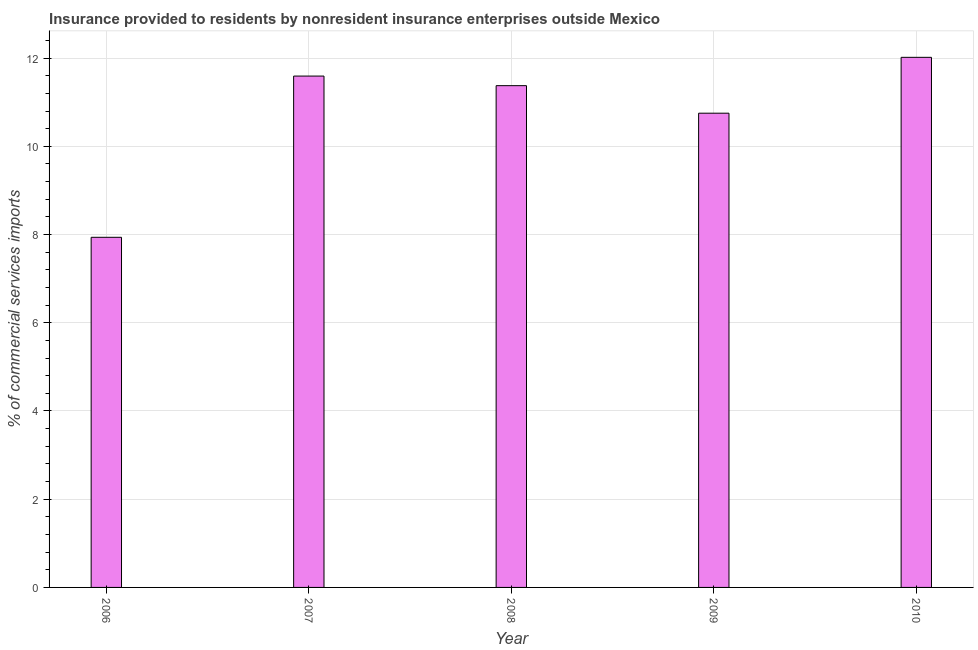Does the graph contain any zero values?
Provide a short and direct response. No. What is the title of the graph?
Provide a succinct answer. Insurance provided to residents by nonresident insurance enterprises outside Mexico. What is the label or title of the X-axis?
Offer a terse response. Year. What is the label or title of the Y-axis?
Keep it short and to the point. % of commercial services imports. What is the insurance provided by non-residents in 2007?
Your response must be concise. 11.59. Across all years, what is the maximum insurance provided by non-residents?
Your answer should be compact. 12.02. Across all years, what is the minimum insurance provided by non-residents?
Keep it short and to the point. 7.94. In which year was the insurance provided by non-residents maximum?
Give a very brief answer. 2010. What is the sum of the insurance provided by non-residents?
Your answer should be very brief. 53.68. What is the difference between the insurance provided by non-residents in 2006 and 2010?
Offer a very short reply. -4.08. What is the average insurance provided by non-residents per year?
Offer a terse response. 10.73. What is the median insurance provided by non-residents?
Offer a terse response. 11.38. What is the ratio of the insurance provided by non-residents in 2009 to that in 2010?
Provide a succinct answer. 0.9. What is the difference between the highest and the second highest insurance provided by non-residents?
Your response must be concise. 0.42. What is the difference between the highest and the lowest insurance provided by non-residents?
Ensure brevity in your answer.  4.08. In how many years, is the insurance provided by non-residents greater than the average insurance provided by non-residents taken over all years?
Your answer should be very brief. 4. How many bars are there?
Ensure brevity in your answer.  5. How many years are there in the graph?
Make the answer very short. 5. What is the difference between two consecutive major ticks on the Y-axis?
Provide a short and direct response. 2. Are the values on the major ticks of Y-axis written in scientific E-notation?
Your answer should be very brief. No. What is the % of commercial services imports in 2006?
Provide a succinct answer. 7.94. What is the % of commercial services imports of 2007?
Offer a terse response. 11.59. What is the % of commercial services imports in 2008?
Your answer should be compact. 11.38. What is the % of commercial services imports of 2009?
Ensure brevity in your answer.  10.75. What is the % of commercial services imports in 2010?
Provide a succinct answer. 12.02. What is the difference between the % of commercial services imports in 2006 and 2007?
Your response must be concise. -3.66. What is the difference between the % of commercial services imports in 2006 and 2008?
Your answer should be very brief. -3.44. What is the difference between the % of commercial services imports in 2006 and 2009?
Keep it short and to the point. -2.81. What is the difference between the % of commercial services imports in 2006 and 2010?
Your answer should be compact. -4.08. What is the difference between the % of commercial services imports in 2007 and 2008?
Make the answer very short. 0.22. What is the difference between the % of commercial services imports in 2007 and 2009?
Your answer should be compact. 0.84. What is the difference between the % of commercial services imports in 2007 and 2010?
Offer a very short reply. -0.42. What is the difference between the % of commercial services imports in 2008 and 2009?
Provide a short and direct response. 0.62. What is the difference between the % of commercial services imports in 2008 and 2010?
Your answer should be compact. -0.64. What is the difference between the % of commercial services imports in 2009 and 2010?
Offer a very short reply. -1.27. What is the ratio of the % of commercial services imports in 2006 to that in 2007?
Your answer should be very brief. 0.69. What is the ratio of the % of commercial services imports in 2006 to that in 2008?
Your answer should be compact. 0.7. What is the ratio of the % of commercial services imports in 2006 to that in 2009?
Keep it short and to the point. 0.74. What is the ratio of the % of commercial services imports in 2006 to that in 2010?
Keep it short and to the point. 0.66. What is the ratio of the % of commercial services imports in 2007 to that in 2008?
Give a very brief answer. 1.02. What is the ratio of the % of commercial services imports in 2007 to that in 2009?
Make the answer very short. 1.08. What is the ratio of the % of commercial services imports in 2007 to that in 2010?
Provide a succinct answer. 0.96. What is the ratio of the % of commercial services imports in 2008 to that in 2009?
Give a very brief answer. 1.06. What is the ratio of the % of commercial services imports in 2008 to that in 2010?
Provide a succinct answer. 0.95. What is the ratio of the % of commercial services imports in 2009 to that in 2010?
Make the answer very short. 0.9. 